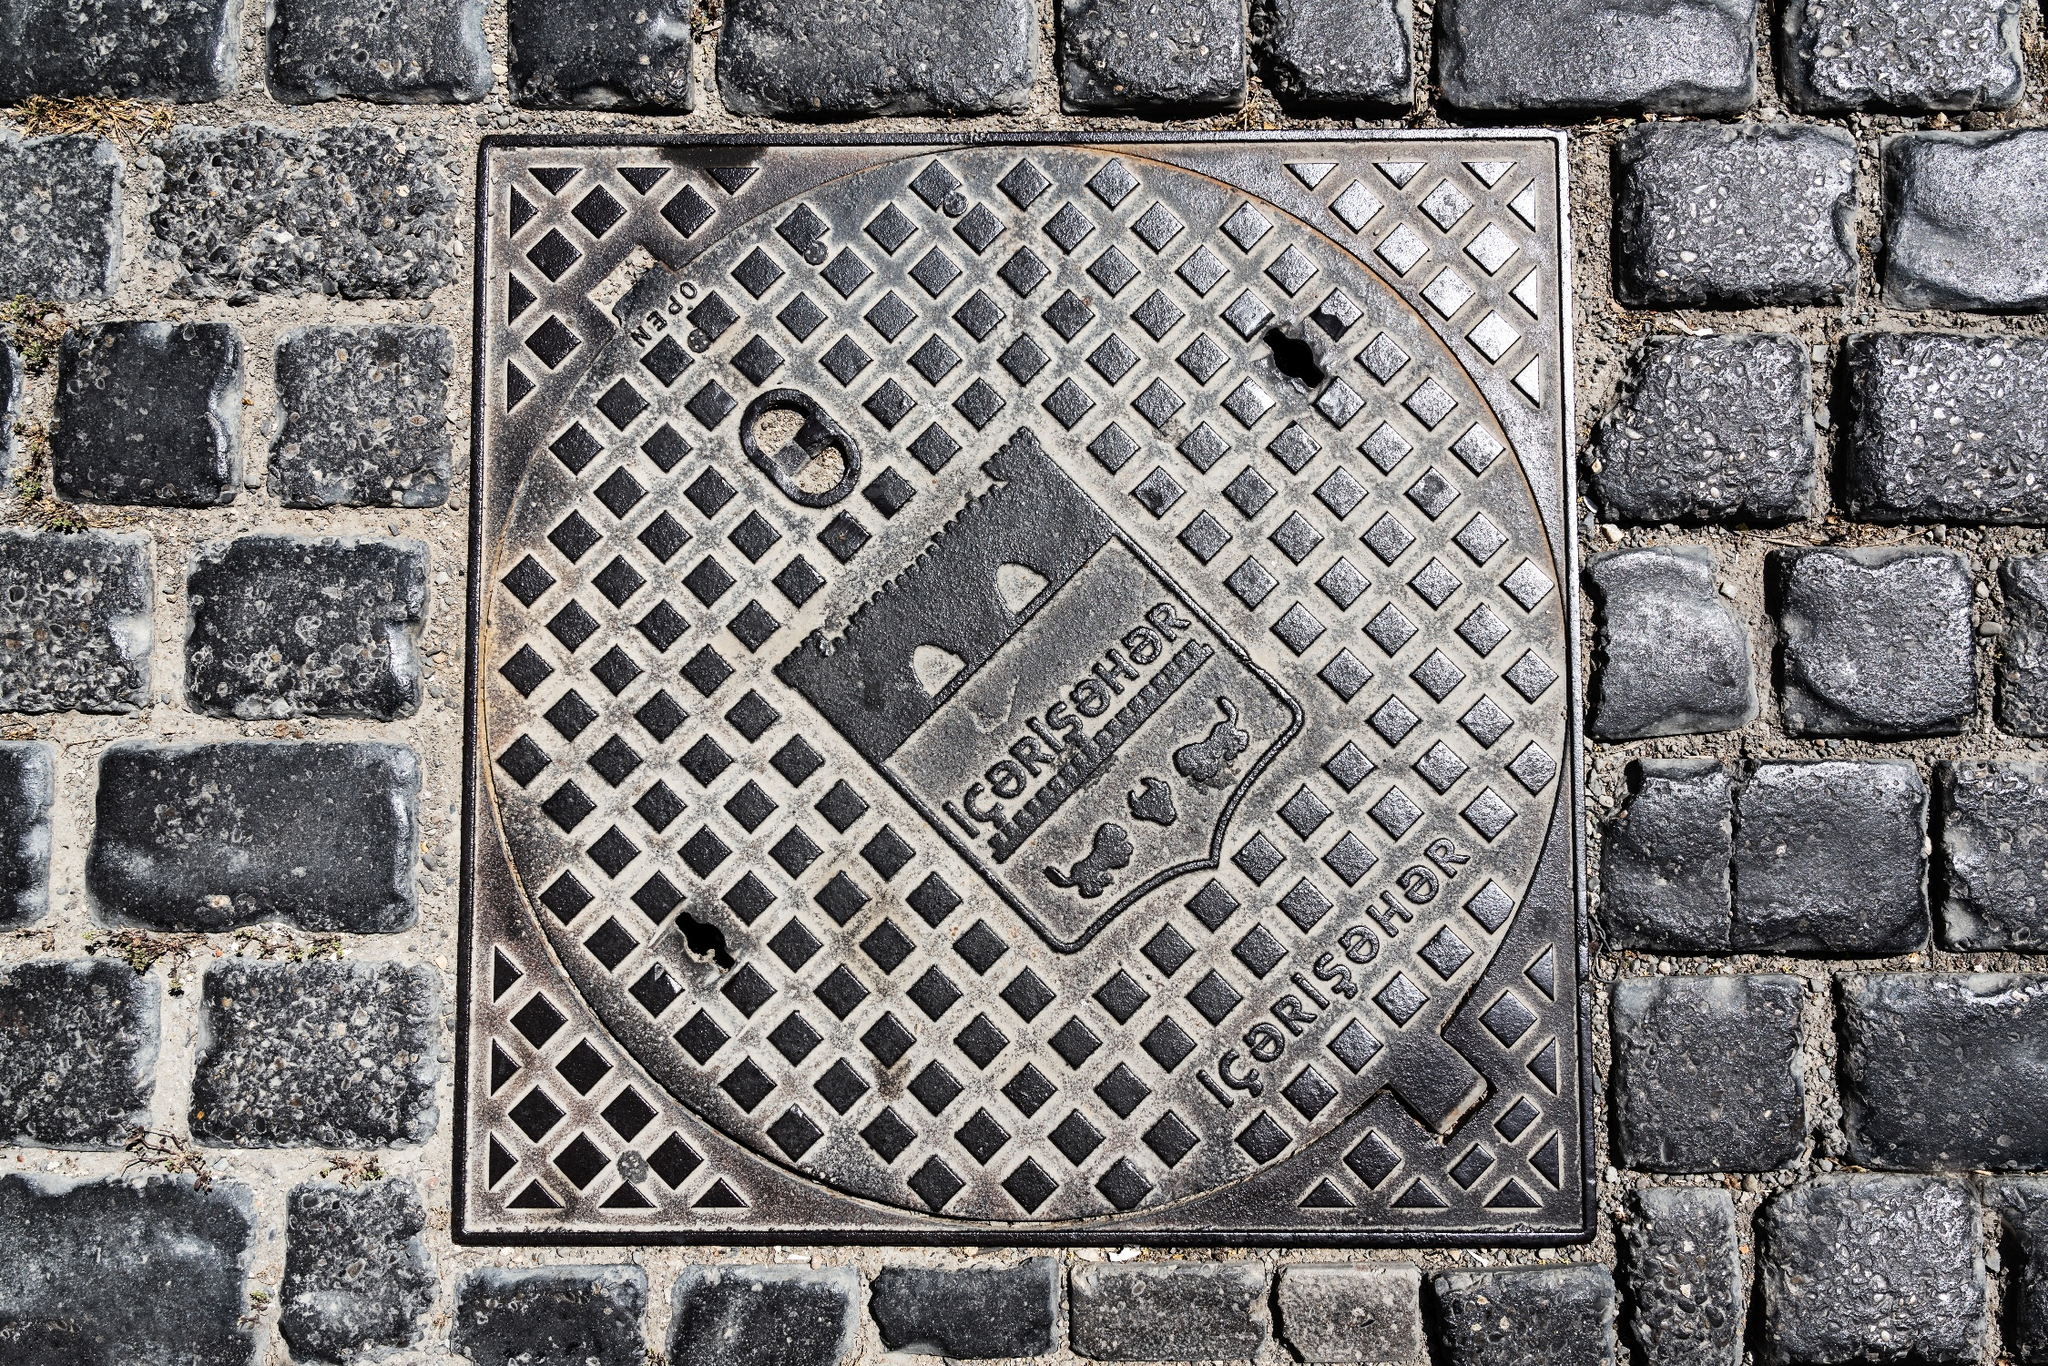Can you tell if this manhole cover has any special significance? Based on the image, the manhole cover has a robust design that serves more than a utilitarian purpose; it features a geometric pattern that might indicate a sense of local pride or a particular aesthetic choice of the area. The presence of the name 'GORENJE' suggests that it may have significance to the place it's found in, perhaps a brand renowned for such infrastructure or a stamp indicating its locality. 